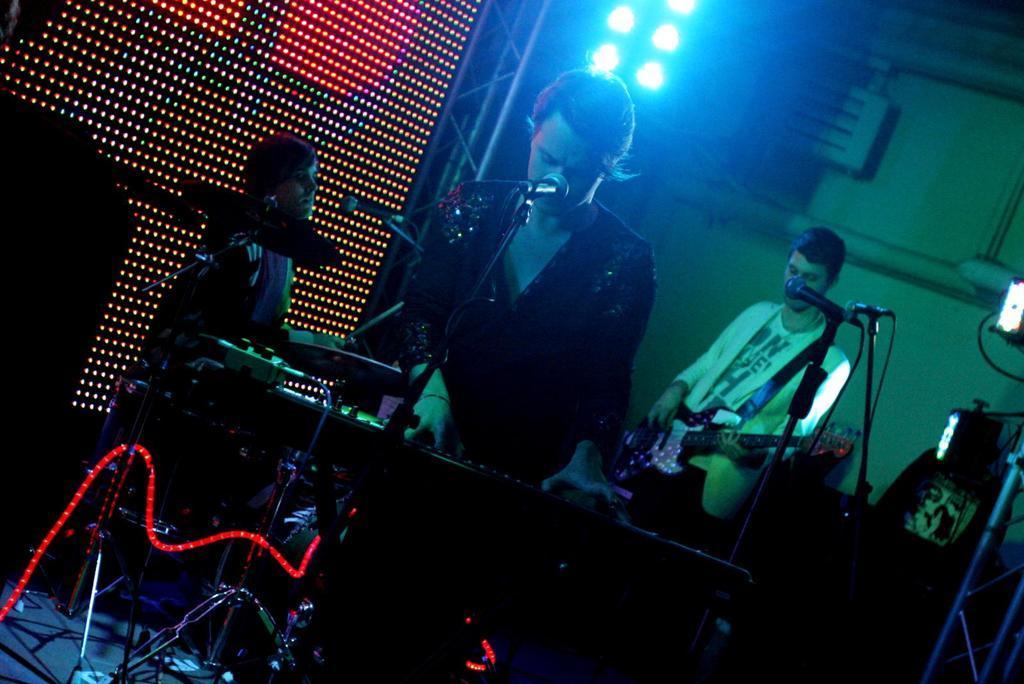In one or two sentences, can you explain what this image depicts? In this picture we can see a person holding a guitar and standing. We can see a man standing. There are microphones, microphone stands, lights, musical instruments and other objects. We can see a person sitting on the left side. 